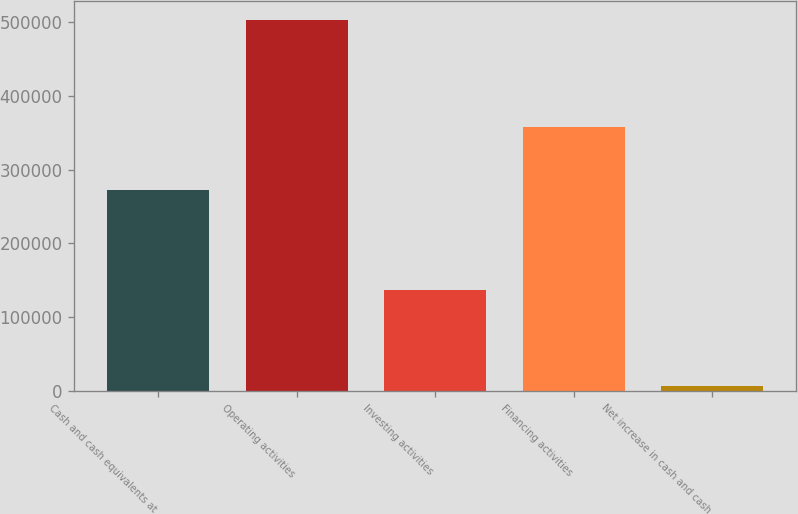Convert chart. <chart><loc_0><loc_0><loc_500><loc_500><bar_chart><fcel>Cash and cash equivalents at<fcel>Operating activities<fcel>Investing activities<fcel>Financing activities<fcel>Net increase in cash and cash<nl><fcel>272684<fcel>502536<fcel>137562<fcel>357492<fcel>7482<nl></chart> 